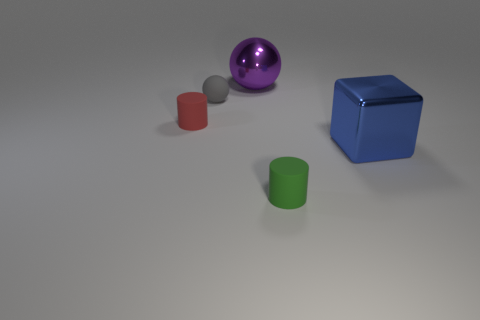There is a shiny ball; is it the same color as the shiny thing that is in front of the red cylinder? No, the shiny ball is not the same color as the other shiny object. The ball has a vivid purple hue, while the object in front of the red cylinder appears to be shiny and silver. 